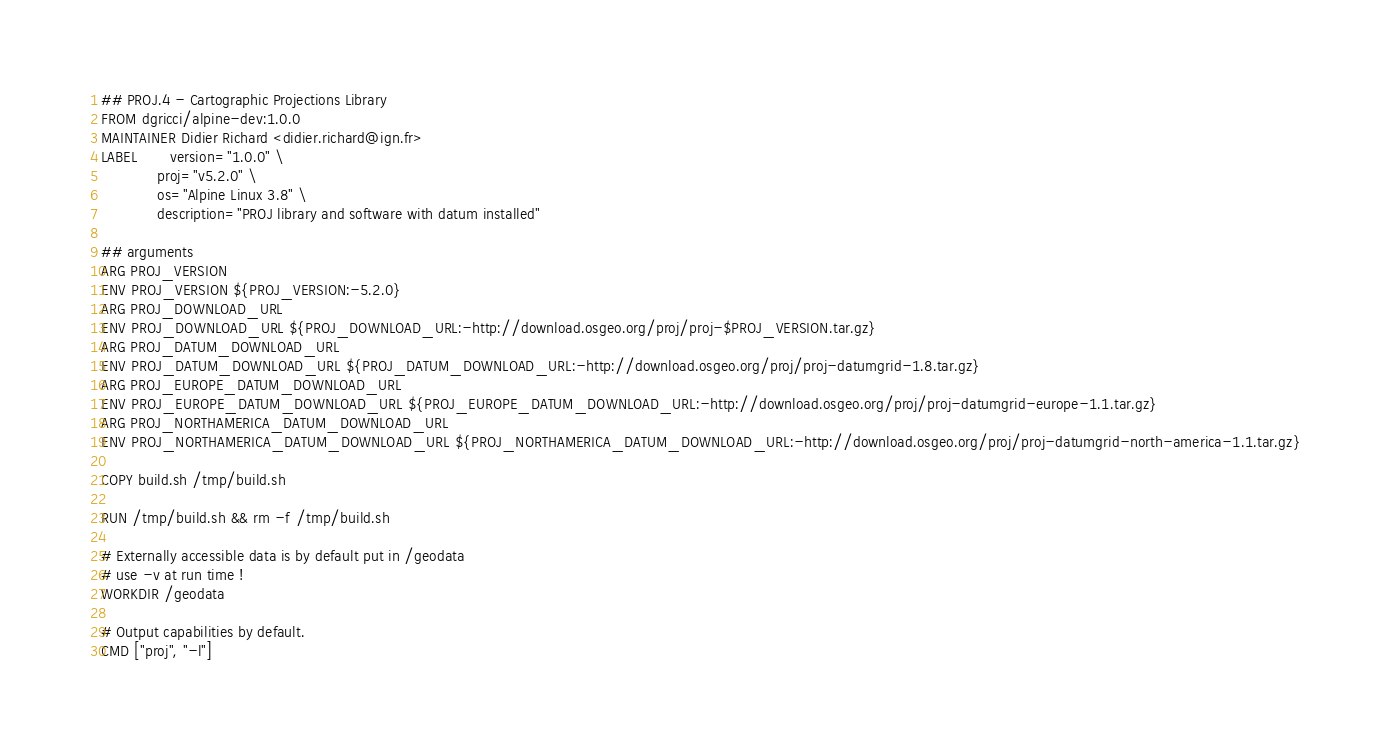Convert code to text. <code><loc_0><loc_0><loc_500><loc_500><_Dockerfile_>## PROJ.4 - Cartographic Projections Library 
FROM dgricci/alpine-dev:1.0.0
MAINTAINER Didier Richard <didier.richard@ign.fr>
LABEL       version="1.0.0" \
            proj="v5.2.0" \
            os="Alpine Linux 3.8" \
            description="PROJ library and software with datum installed"

## arguments
ARG PROJ_VERSION
ENV PROJ_VERSION ${PROJ_VERSION:-5.2.0}
ARG PROJ_DOWNLOAD_URL
ENV PROJ_DOWNLOAD_URL ${PROJ_DOWNLOAD_URL:-http://download.osgeo.org/proj/proj-$PROJ_VERSION.tar.gz}
ARG PROJ_DATUM_DOWNLOAD_URL
ENV PROJ_DATUM_DOWNLOAD_URL ${PROJ_DATUM_DOWNLOAD_URL:-http://download.osgeo.org/proj/proj-datumgrid-1.8.tar.gz}
ARG PROJ_EUROPE_DATUM_DOWNLOAD_URL
ENV PROJ_EUROPE_DATUM_DOWNLOAD_URL ${PROJ_EUROPE_DATUM_DOWNLOAD_URL:-http://download.osgeo.org/proj/proj-datumgrid-europe-1.1.tar.gz}
ARG PROJ_NORTHAMERICA_DATUM_DOWNLOAD_URL
ENV PROJ_NORTHAMERICA_DATUM_DOWNLOAD_URL ${PROJ_NORTHAMERICA_DATUM_DOWNLOAD_URL:-http://download.osgeo.org/proj/proj-datumgrid-north-america-1.1.tar.gz}

COPY build.sh /tmp/build.sh

RUN /tmp/build.sh && rm -f /tmp/build.sh

# Externally accessible data is by default put in /geodata
# use -v at run time !
WORKDIR /geodata

# Output capabilities by default.
CMD ["proj", "-l"]

</code> 